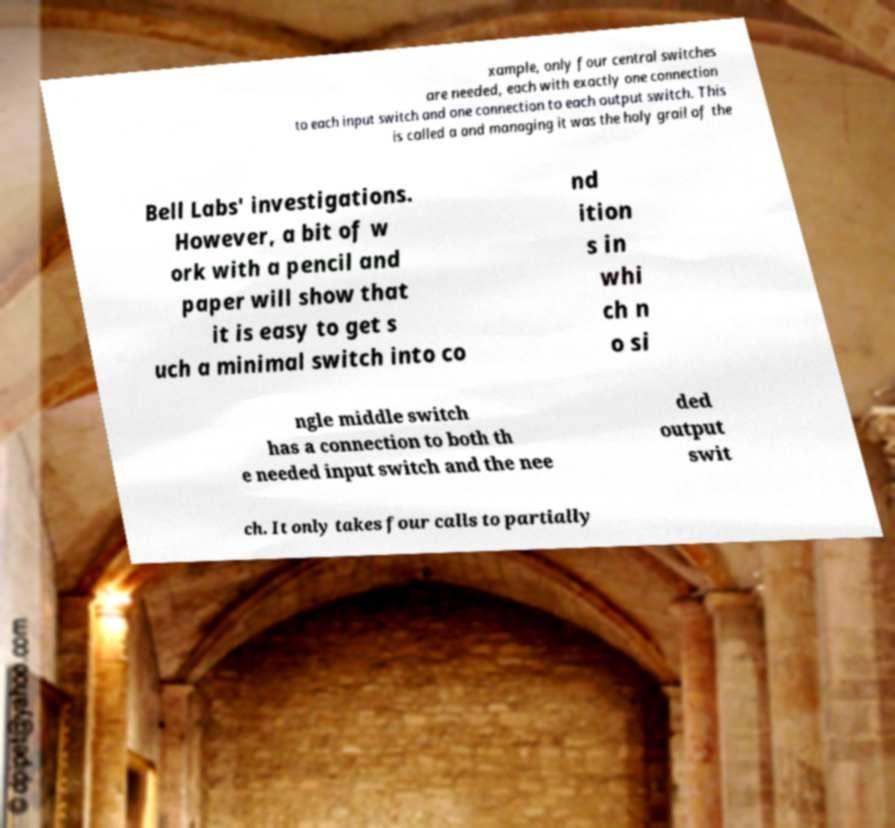Could you extract and type out the text from this image? xample, only four central switches are needed, each with exactly one connection to each input switch and one connection to each output switch. This is called a and managing it was the holy grail of the Bell Labs' investigations. However, a bit of w ork with a pencil and paper will show that it is easy to get s uch a minimal switch into co nd ition s in whi ch n o si ngle middle switch has a connection to both th e needed input switch and the nee ded output swit ch. It only takes four calls to partially 